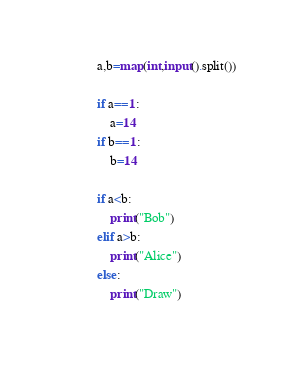<code> <loc_0><loc_0><loc_500><loc_500><_Python_>
a,b=map(int,input().split())

if a==1:
    a=14
if b==1:
    b=14

if a<b:
    print("Bob")
elif a>b:
    print("Alice")
else:
    print("Draw")
</code> 